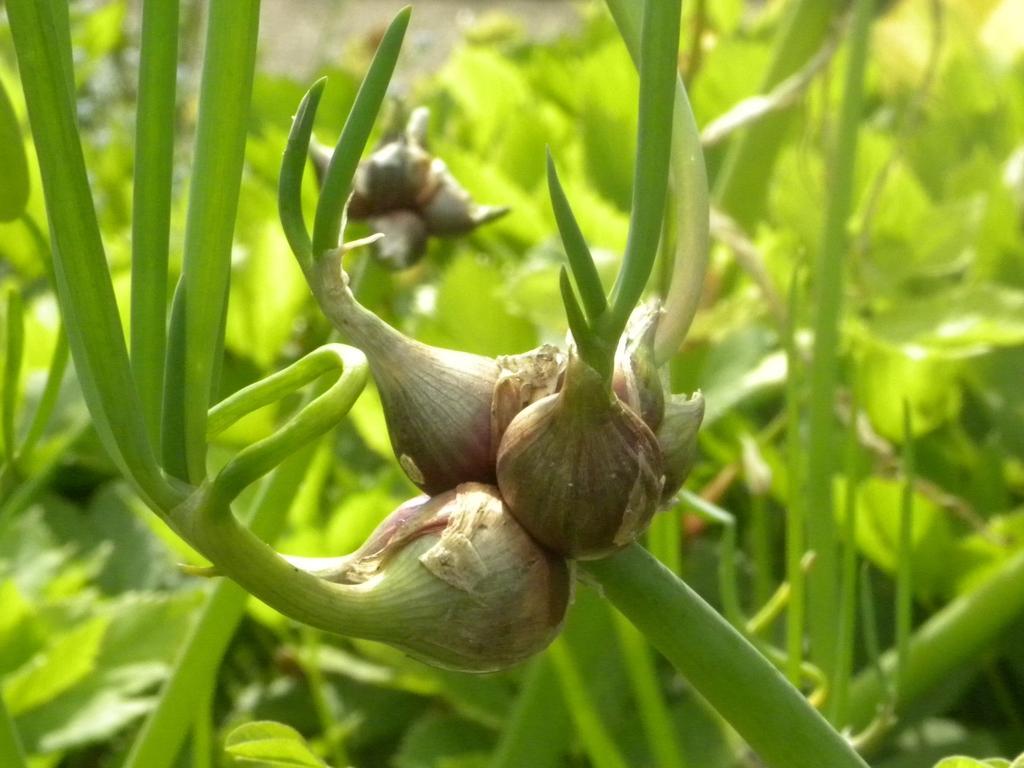In one or two sentences, can you explain what this image depicts? In this image we can see onions to the plants. 